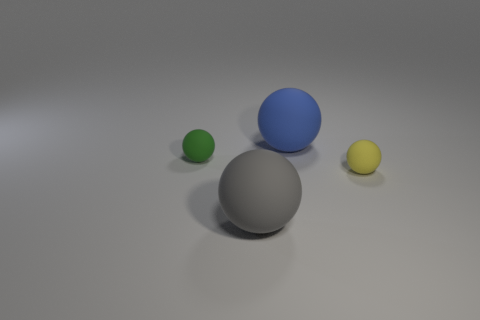What number of objects are spheres left of the gray ball or tiny green balls?
Offer a terse response. 1. What material is the tiny object to the left of the large rubber object that is in front of the matte sphere that is right of the big blue matte sphere?
Keep it short and to the point. Rubber. Are there more small green spheres that are to the left of the gray thing than yellow rubber spheres that are behind the large blue ball?
Your answer should be compact. Yes. How many blocks are small green things or yellow objects?
Keep it short and to the point. 0. There is a tiny matte ball on the left side of the thing in front of the yellow ball; what number of large blue matte spheres are on the left side of it?
Provide a short and direct response. 0. Is the number of yellow rubber balls greater than the number of tiny matte things?
Your answer should be very brief. No. Does the yellow rubber object have the same size as the gray rubber ball?
Make the answer very short. No. What number of objects are either tiny things or large gray things?
Provide a succinct answer. 3. There is a large object behind the ball that is left of the big ball in front of the small green matte object; what is its shape?
Your answer should be very brief. Sphere. Does the small thing that is left of the small yellow rubber thing have the same material as the small thing that is right of the large gray ball?
Ensure brevity in your answer.  Yes. 